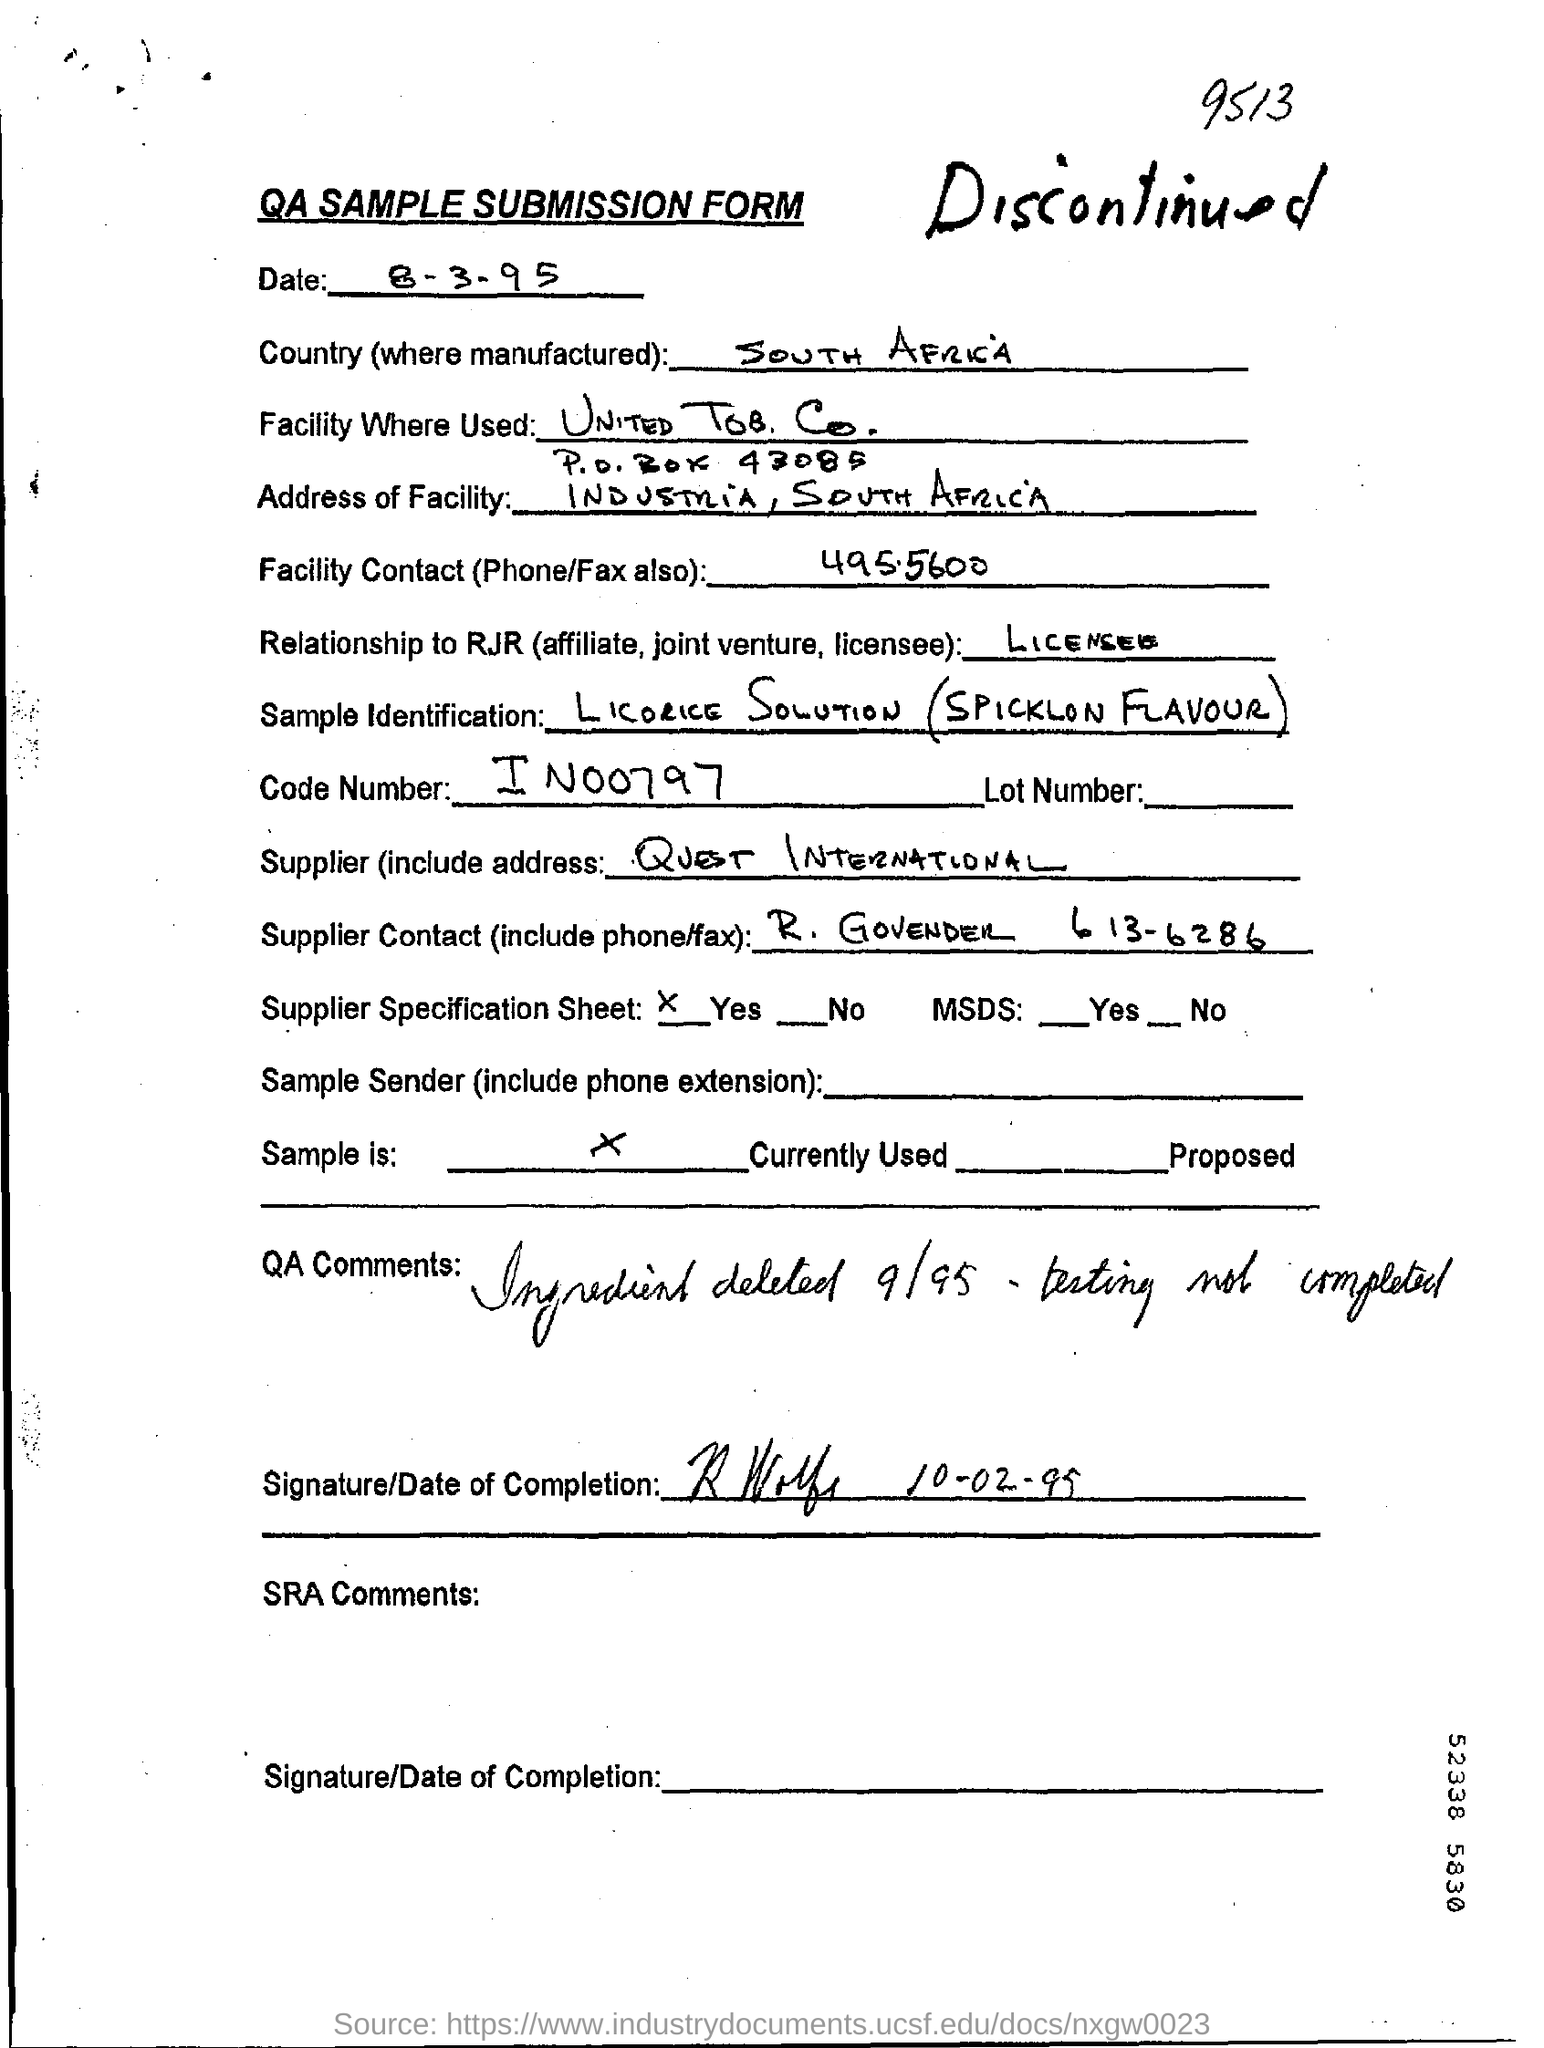What is the date mentioned?
Give a very brief answer. 8-3-95. What is the Code Number?
Your answer should be very brief. IN00797. What is the Country mentioned in the form?
Give a very brief answer. SOUTH AFRICA. 